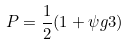<formula> <loc_0><loc_0><loc_500><loc_500>P = \frac { 1 } { 2 } ( 1 + \psi g 3 )</formula> 